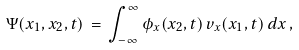Convert formula to latex. <formula><loc_0><loc_0><loc_500><loc_500>\Psi ( x _ { 1 } , x _ { 2 } , t ) \, = \, \int _ { - \infty } ^ { \infty } \phi _ { x } ( x _ { 2 } , t ) \, v _ { x } ( x _ { 1 } , t ) \, d x \, ,</formula> 